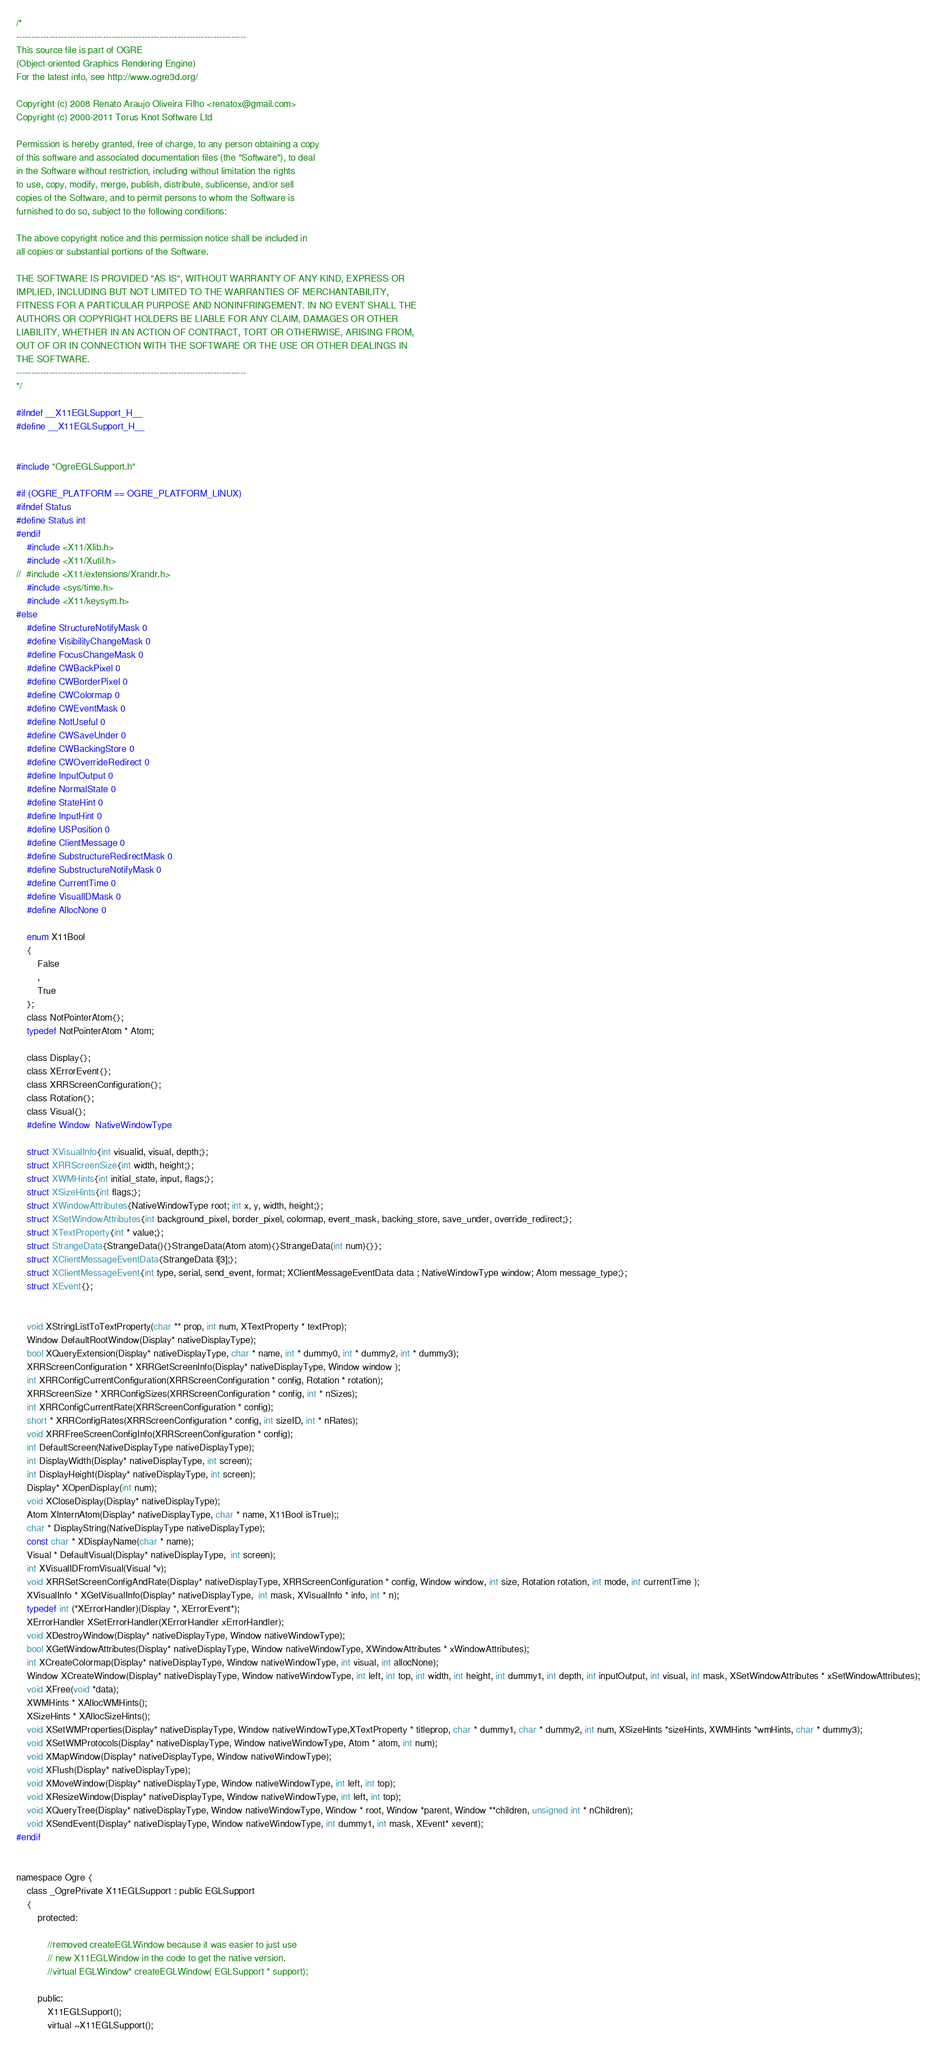Convert code to text. <code><loc_0><loc_0><loc_500><loc_500><_C_>/*
-----------------------------------------------------------------------------
This source file is part of OGRE
(Object-oriented Graphics Rendering Engine)
For the latest info, see http://www.ogre3d.org/

Copyright (c) 2008 Renato Araujo Oliveira Filho <renatox@gmail.com>
Copyright (c) 2000-2011 Torus Knot Software Ltd

Permission is hereby granted, free of charge, to any person obtaining a copy
of this software and associated documentation files (the "Software"), to deal
in the Software without restriction, including without limitation the rights
to use, copy, modify, merge, publish, distribute, sublicense, and/or sell
copies of the Software, and to permit persons to whom the Software is
furnished to do so, subject to the following conditions:

The above copyright notice and this permission notice shall be included in
all copies or substantial portions of the Software.

THE SOFTWARE IS PROVIDED "AS IS", WITHOUT WARRANTY OF ANY KIND, EXPRESS OR
IMPLIED, INCLUDING BUT NOT LIMITED TO THE WARRANTIES OF MERCHANTABILITY,
FITNESS FOR A PARTICULAR PURPOSE AND NONINFRINGEMENT. IN NO EVENT SHALL THE
AUTHORS OR COPYRIGHT HOLDERS BE LIABLE FOR ANY CLAIM, DAMAGES OR OTHER
LIABILITY, WHETHER IN AN ACTION OF CONTRACT, TORT OR OTHERWISE, ARISING FROM,
OUT OF OR IN CONNECTION WITH THE SOFTWARE OR THE USE OR OTHER DEALINGS IN
THE SOFTWARE.
-----------------------------------------------------------------------------
*/

#ifndef __X11EGLSupport_H__
#define __X11EGLSupport_H__


#include "OgreEGLSupport.h"

#if (OGRE_PLATFORM == OGRE_PLATFORM_LINUX)
#ifndef Status
#define Status int
#endif 
	#include <X11/Xlib.h>
	#include <X11/Xutil.h>
//	#include <X11/extensions/Xrandr.h>
	#include <sys/time.h>
	#include <X11/keysym.h>
#else
	#define StructureNotifyMask 0
	#define VisibilityChangeMask 0
	#define FocusChangeMask 0
	#define CWBackPixel 0
	#define CWBorderPixel 0
	#define CWColormap 0
	#define CWEventMask 0
	#define NotUseful 0
	#define CWSaveUnder 0
	#define CWBackingStore 0
	#define CWOverrideRedirect 0
	#define InputOutput 0
	#define NormalState 0
	#define StateHint 0
	#define InputHint 0
	#define USPosition 0
	#define ClientMessage 0
	#define SubstructureRedirectMask 0
	#define SubstructureNotifyMask 0
	#define CurrentTime 0
	#define VisualIDMask 0
	#define AllocNone 0

	enum X11Bool
	{
		False
		,
		True
	};
	class NotPointerAtom{};
	typedef NotPointerAtom * Atom;

	class Display{};
	class XErrorEvent{};
	class XRRScreenConfiguration{};
	class Rotation{};
	class Visual{};
	#define Window  NativeWindowType

	struct XVisualInfo{int visualid, visual, depth;};
	struct XRRScreenSize{int width, height;};
	struct XWMHints{int initial_state, input, flags;};
	struct XSizeHints{int flags;};
	struct XWindowAttributes{NativeWindowType root; int x, y, width, height;};
	struct XSetWindowAttributes{int background_pixel, border_pixel, colormap, event_mask, backing_store, save_under, override_redirect;};
	struct XTextProperty{int * value;};
	struct StrangeData{StrangeData(){}StrangeData(Atom atom){}StrangeData(int num){}};
	struct XClientMessageEventData{StrangeData l[3];};
	struct XClientMessageEvent{int type, serial, send_event, format; XClientMessageEventData data ; NativeWindowType window; Atom message_type;};
	struct XEvent{};


	void XStringListToTextProperty(char ** prop, int num, XTextProperty * textProp);
	Window DefaultRootWindow(Display* nativeDisplayType);
	bool XQueryExtension(Display* nativeDisplayType, char * name, int * dummy0, int * dummy2, int * dummy3);
	XRRScreenConfiguration * XRRGetScreenInfo(Display* nativeDisplayType, Window window );
	int XRRConfigCurrentConfiguration(XRRScreenConfiguration * config, Rotation * rotation);
	XRRScreenSize * XRRConfigSizes(XRRScreenConfiguration * config, int * nSizes);
	int XRRConfigCurrentRate(XRRScreenConfiguration * config);
	short * XRRConfigRates(XRRScreenConfiguration * config, int sizeID, int * nRates);
	void XRRFreeScreenConfigInfo(XRRScreenConfiguration * config);
	int DefaultScreen(NativeDisplayType nativeDisplayType);
	int DisplayWidth(Display* nativeDisplayType, int screen);
	int DisplayHeight(Display* nativeDisplayType, int screen);
	Display* XOpenDisplay(int num);
	void XCloseDisplay(Display* nativeDisplayType);
	Atom XInternAtom(Display* nativeDisplayType, char * name, X11Bool isTrue);;
	char * DisplayString(NativeDisplayType nativeDisplayType);
	const char * XDisplayName(char * name);
	Visual * DefaultVisual(Display* nativeDisplayType,  int screen);
	int XVisualIDFromVisual(Visual *v);
	void XRRSetScreenConfigAndRate(Display* nativeDisplayType, XRRScreenConfiguration * config, Window window, int size, Rotation rotation, int mode, int currentTime );
	XVisualInfo * XGetVisualInfo(Display* nativeDisplayType,  int mask, XVisualInfo * info, int * n);
	typedef int (*XErrorHandler)(Display *, XErrorEvent*);
	XErrorHandler XSetErrorHandler(XErrorHandler xErrorHandler);
	void XDestroyWindow(Display* nativeDisplayType, Window nativeWindowType);
	bool XGetWindowAttributes(Display* nativeDisplayType, Window nativeWindowType, XWindowAttributes * xWindowAttributes);
	int XCreateColormap(Display* nativeDisplayType, Window nativeWindowType, int visual, int allocNone);
	Window XCreateWindow(Display* nativeDisplayType, Window nativeWindowType, int left, int top, int width, int height, int dummy1, int depth, int inputOutput, int visual, int mask, XSetWindowAttributes * xSetWindowAttributes);
	void XFree(void *data);
	XWMHints * XAllocWMHints();
	XSizeHints * XAllocSizeHints();
	void XSetWMProperties(Display* nativeDisplayType, Window nativeWindowType,XTextProperty * titleprop, char * dummy1, char * dummy2, int num, XSizeHints *sizeHints, XWMHints *wmHints, char * dummy3);
	void XSetWMProtocols(Display* nativeDisplayType, Window nativeWindowType, Atom * atom, int num);
	void XMapWindow(Display* nativeDisplayType, Window nativeWindowType);
	void XFlush(Display* nativeDisplayType);
	void XMoveWindow(Display* nativeDisplayType, Window nativeWindowType, int left, int top);
	void XResizeWindow(Display* nativeDisplayType, Window nativeWindowType, int left, int top);
	void XQueryTree(Display* nativeDisplayType, Window nativeWindowType, Window * root, Window *parent, Window **children, unsigned int * nChildren);
	void XSendEvent(Display* nativeDisplayType, Window nativeWindowType, int dummy1, int mask, XEvent* xevent);
#endif


namespace Ogre {
    class _OgrePrivate X11EGLSupport : public EGLSupport
    {
		protected:

			//removed createEGLWindow because it was easier to just use
			// new X11EGLWindow in the code to get the native version.
			//virtual EGLWindow* createEGLWindow( EGLSupport * support);

        public:
            X11EGLSupport();
            virtual ~X11EGLSupport();
</code> 